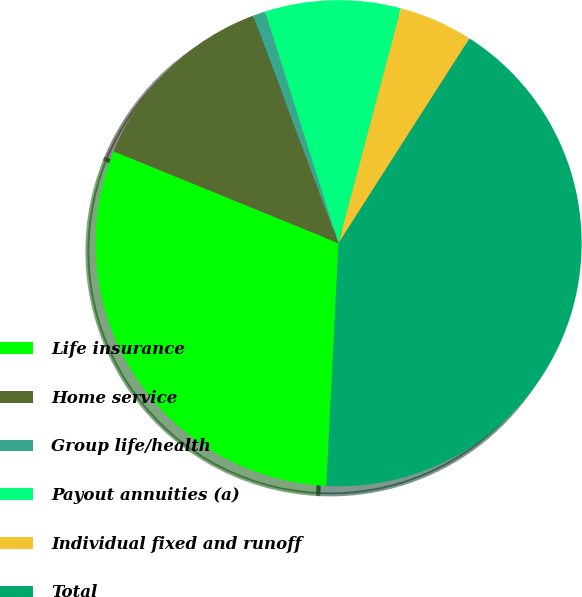Convert chart to OTSL. <chart><loc_0><loc_0><loc_500><loc_500><pie_chart><fcel>Life insurance<fcel>Home service<fcel>Group life/health<fcel>Payout annuities (a)<fcel>Individual fixed and runoff<fcel>Total<nl><fcel>30.37%<fcel>13.11%<fcel>0.83%<fcel>9.02%<fcel>4.92%<fcel>41.75%<nl></chart> 